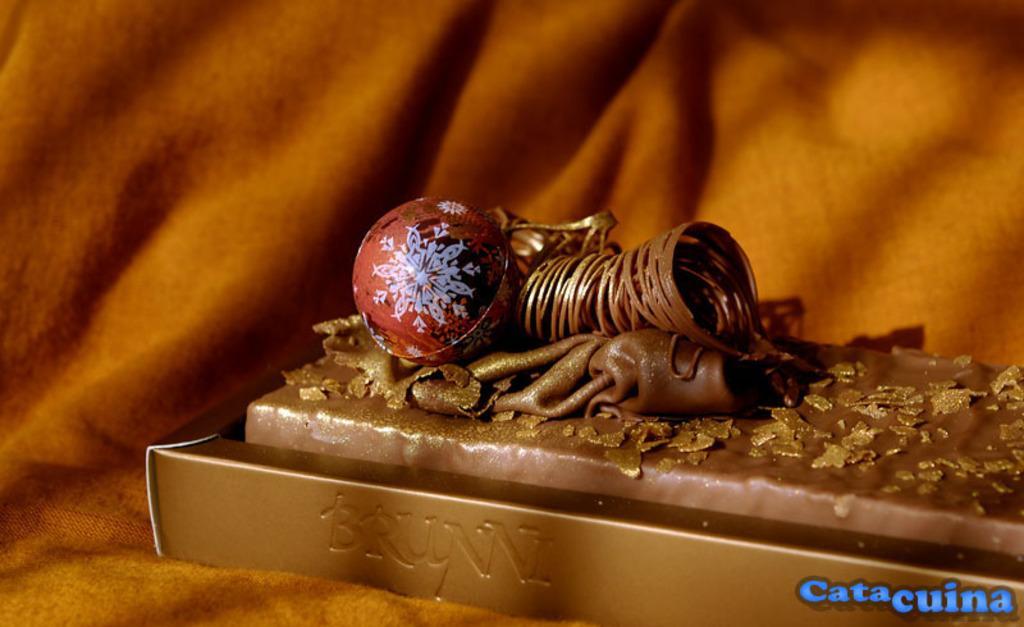Can you describe this image briefly? In this image, we can see a chocolate bar with toppings in the box. This box is placed on the cloth. Background there is a blur view. On the right side bottom corner, we can see some text. 